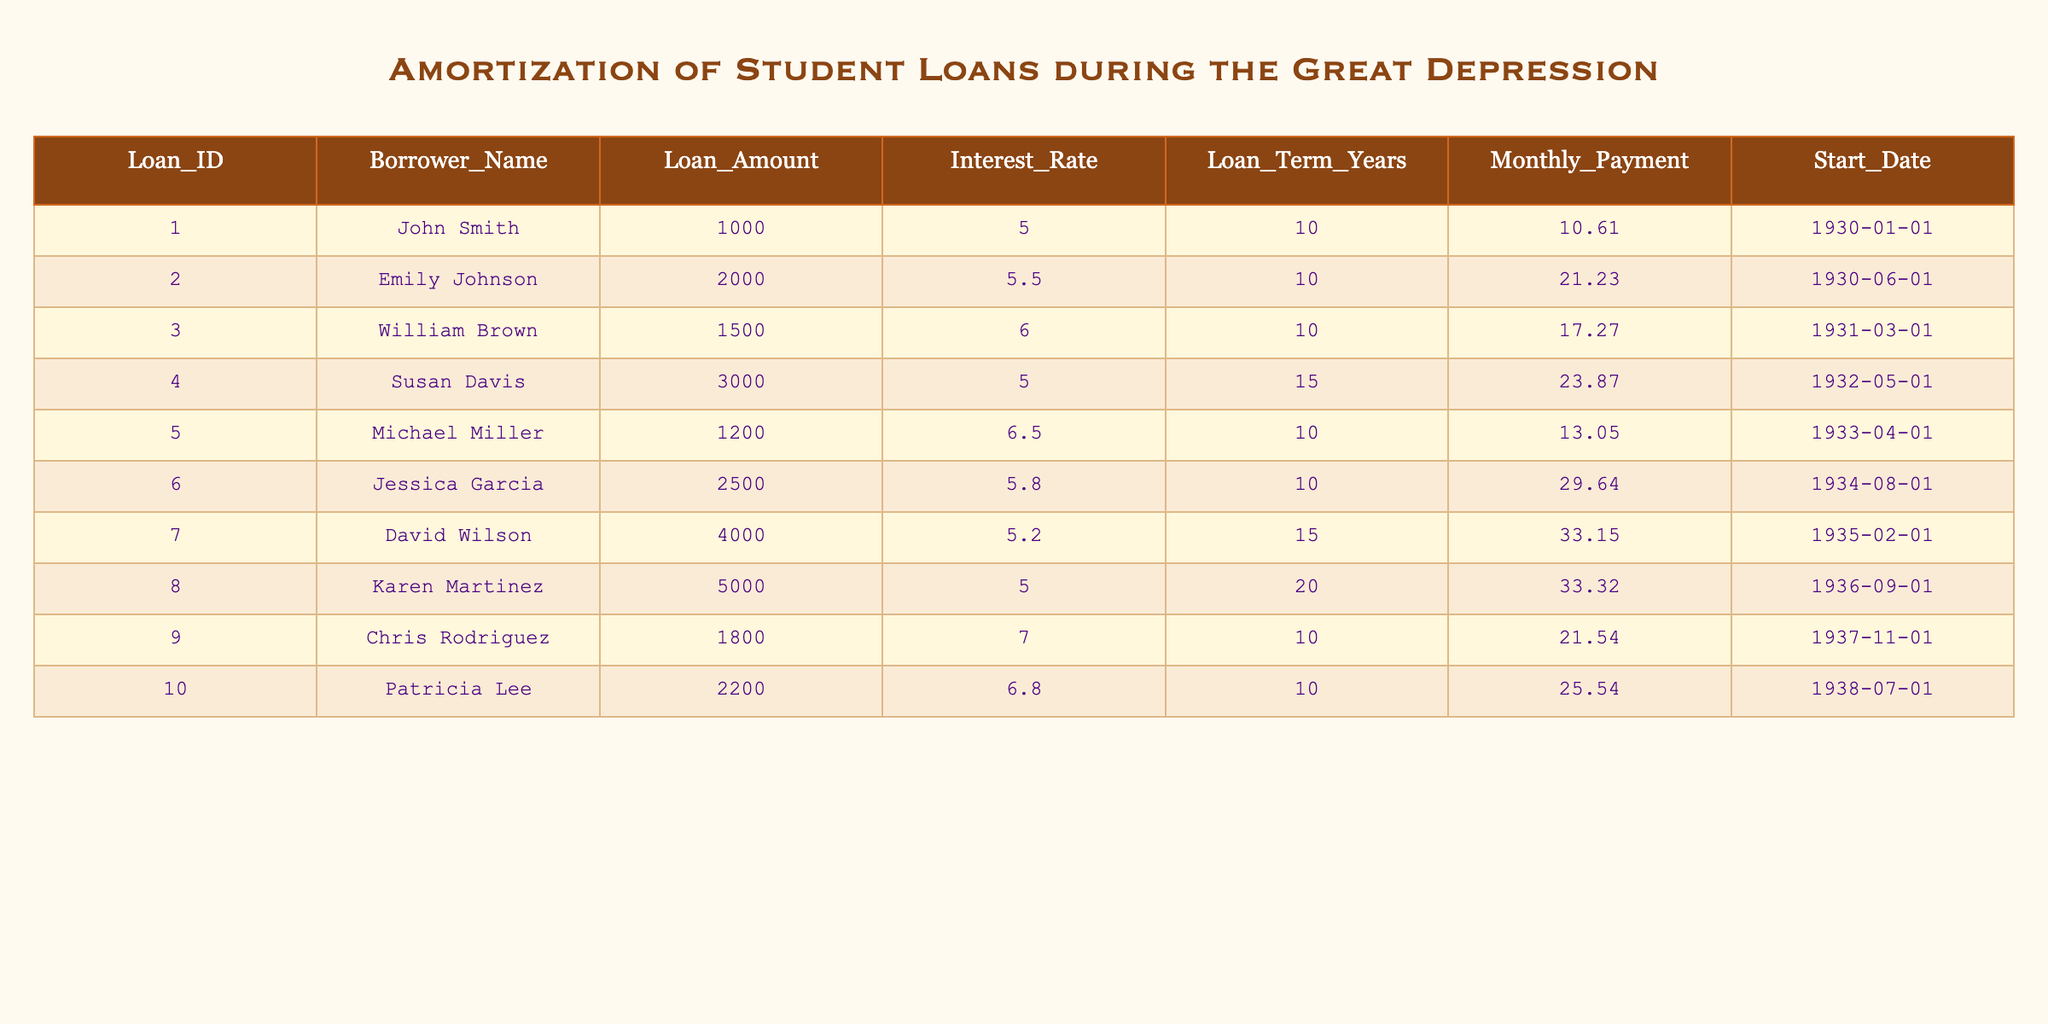What is the loan amount for Jessica Garcia? The loan amount for Jessica Garcia is explicitly listed in the table under the "Loan_Amount" column next to her name. It shows 2500.
Answer: 2500 Which borrower has the highest monthly payment? By looking at the "Monthly_Payment" column, we can read through the values. The highest payment listed is 33.32 for Karen Martinez.
Answer: 33.32 What is the average interest rate for all loans? To find the average interest rate, sum the interest rates (5.0 + 5.5 + 6.0 + 5.0 + 6.5 + 5.8 + 5.2 + 5.0 + 7.0 + 6.8) = 57.8. Since there are 10 loans, the average is 57.8 / 10 = 5.78.
Answer: 5.78 Did John Smith take out a loan with an interest rate above 5%? Checking John Smith's entry in the table, he has an interest rate of 5.0%, which is not above 5%. Therefore, the answer is no.
Answer: No What is the total loan amount for borrowers with an interest rate below 6%? We identify the borrowers with an interest rate below 6%: John Smith (1000), Emily Johnson (2000), Susan Davis (3000), and Karen Martinez (5000). Adding these amounts together: 1000 + 2000 + 3000 + 5000 = 11000.
Answer: 11000 Which loan has the longest term, and what is that term? Inspecting the "Loan_Term_Years" column will reveal that loans with a term of 20 years to Karen Martinez stand out. This is the longest term listed in the table.
Answer: 20 In which year did Susan Davis start her loan? Looking at the "Start_Date" for Susan Davis in the table shows the date 1932-05-01. This indicates she started her loan in May 1932.
Answer: 1932 How many borrowers have a loan term of more than 15 years? We look at the "Loan_Term_Years" column. Only Karen Martinez (20 years) fits this criterion. Therefore, there is just one borrower with a term over 15 years.
Answer: 1 What is the difference between the highest and lowest loan amounts? The highest loan amount is 5000 (Karen Martinez), and the lowest is 1000 (John Smith). The difference is calculated as 5000 - 1000 = 4000.
Answer: 4000 